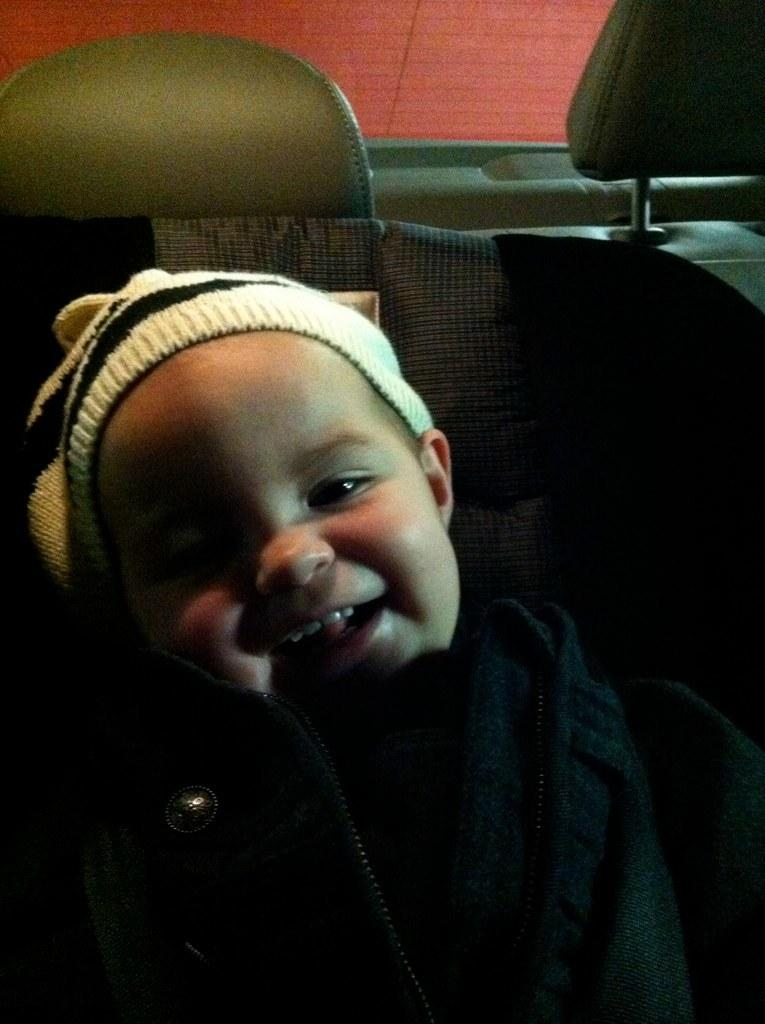What is the main subject of the image? The main subject of the image is a baby. What is the baby wearing in the image? The baby is wearing clothes and a cap. What is the baby's facial expression in the image? The baby is smiling in the image. What object is present in the image that might be used for transportation? There is a vehicle seat in the image. What type of boundary can be seen in the image? There is no boundary present in the image. What type of spoon is being used by the baby in the image? There is no spoon present in the image. 